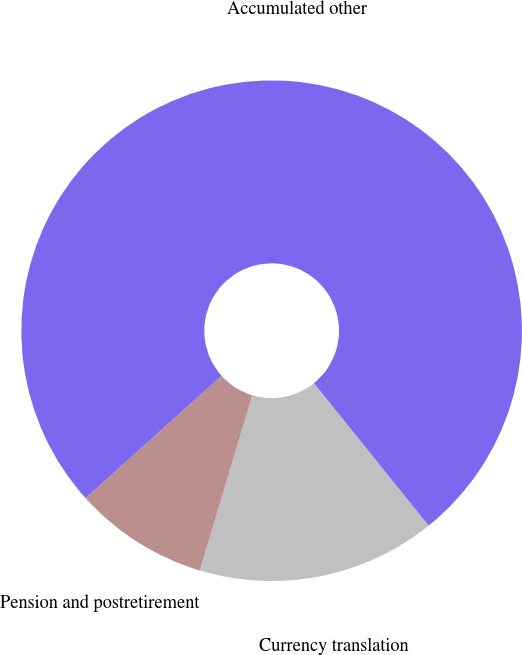Convert chart to OTSL. <chart><loc_0><loc_0><loc_500><loc_500><pie_chart><fcel>Currency translation<fcel>Pension and postretirement<fcel>Accumulated other<nl><fcel>15.43%<fcel>8.71%<fcel>75.87%<nl></chart> 